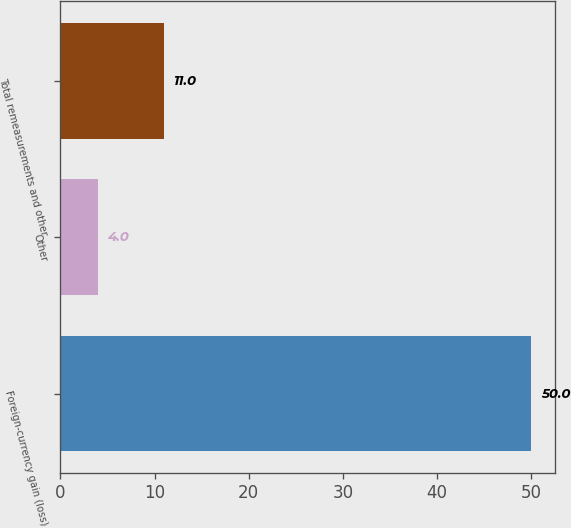Convert chart to OTSL. <chart><loc_0><loc_0><loc_500><loc_500><bar_chart><fcel>Foreign-currency gain (loss)<fcel>Other<fcel>Total remeasurements and other<nl><fcel>50<fcel>4<fcel>11<nl></chart> 